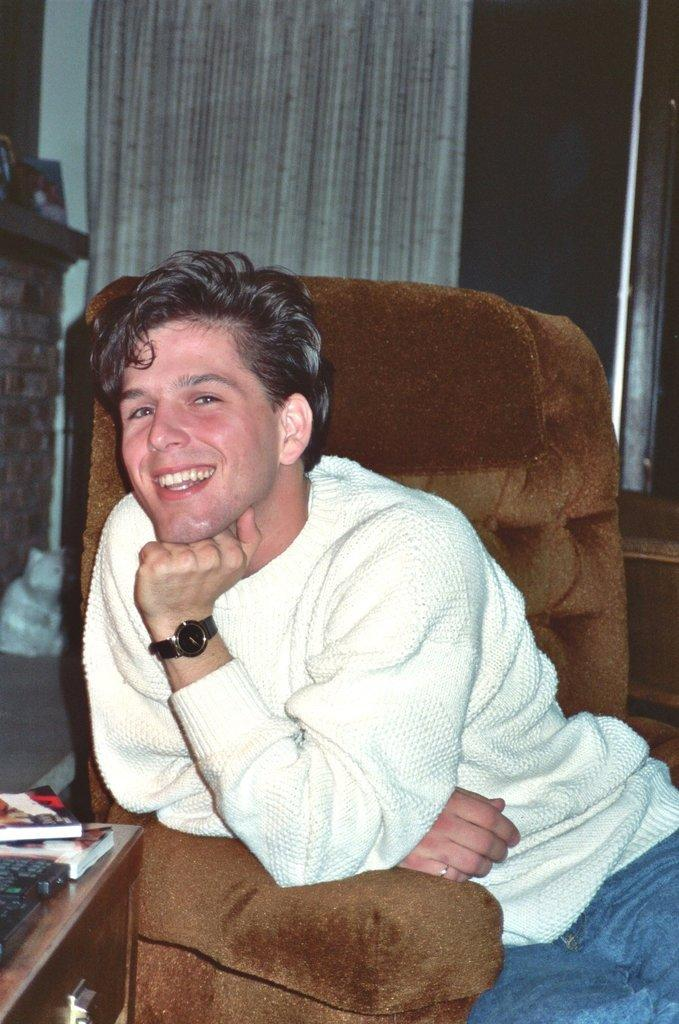What is the person in the image doing? There is a person sitting on a chair in the image. What can be seen in the background of the image? There is a curtain at the back side of the image. What objects are on the table in the image? There are books on a table in the image. What type of store is visible in the image? There is no store present in the image. How does the person in the image show respect to others? The image does not provide information about the person's actions or expressions, so it cannot be determined if they are showing respect to others. 